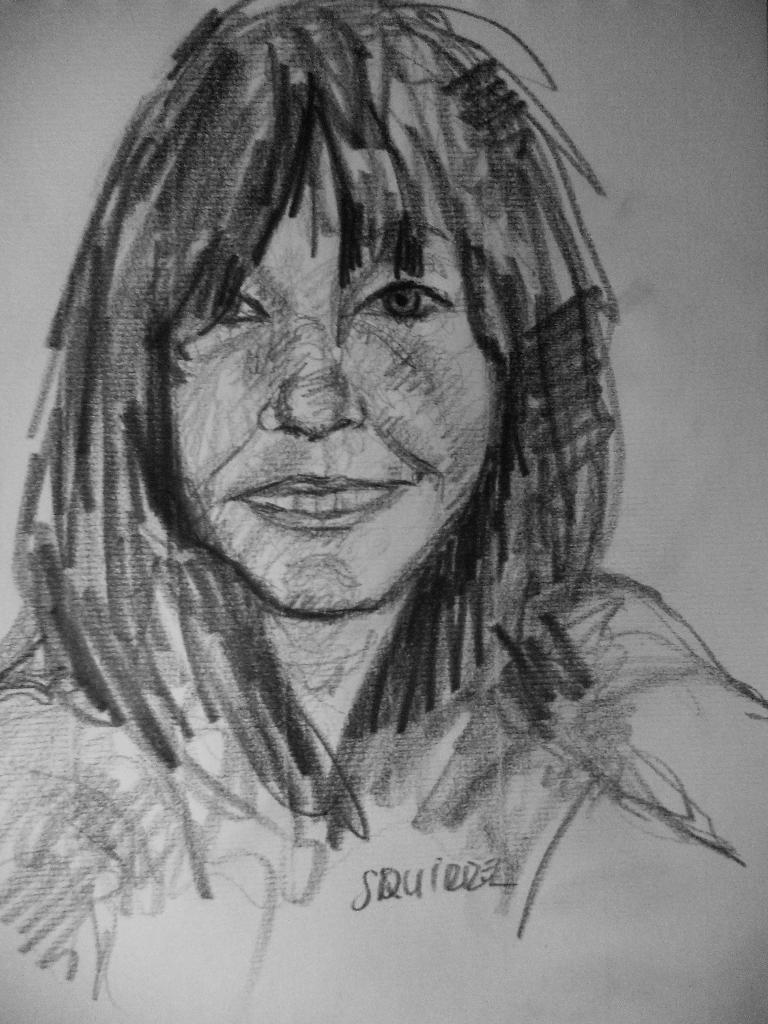What is depicted in the image? There is a sketch of a person in the image. Where are the flowers located in the image? There are no flowers present in the image; it only contains a sketch of a person. 